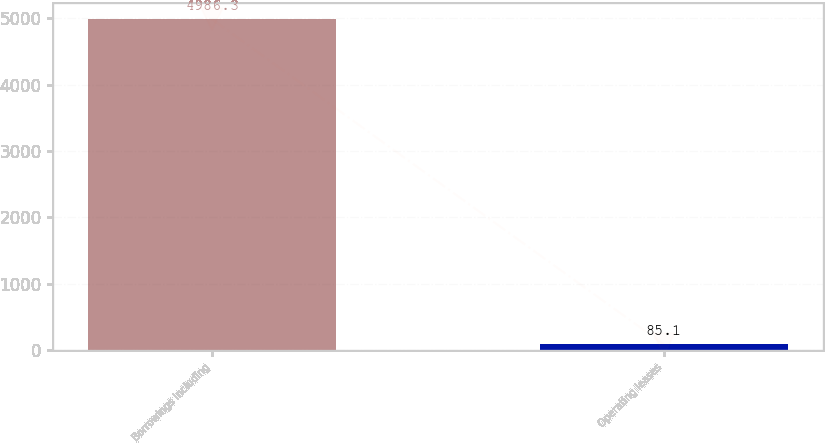Convert chart. <chart><loc_0><loc_0><loc_500><loc_500><bar_chart><fcel>Borrowings including<fcel>Operating leases<nl><fcel>4986.3<fcel>85.1<nl></chart> 